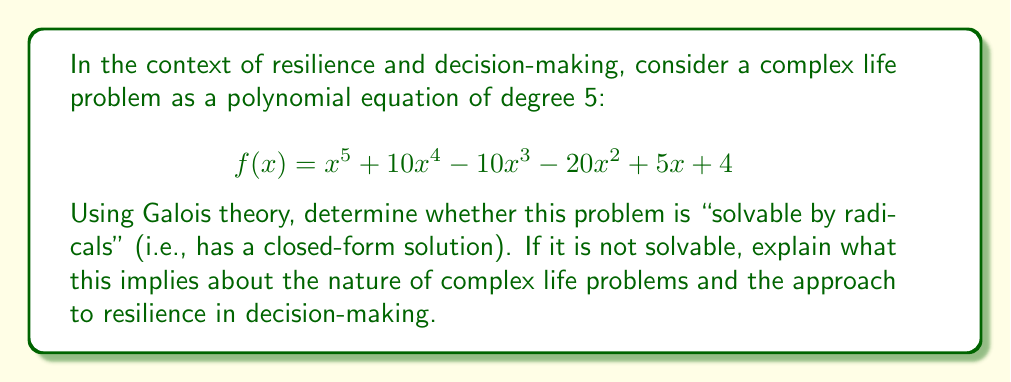What is the answer to this math problem? To determine if the polynomial is solvable by radicals, we'll use Galois theory:

1) First, we need to determine if the polynomial is irreducible over $\mathbb{Q}$. We can use Eisenstein's criterion with the prime $p=2$:
   - The leading coefficient is not divisible by 2
   - All other coefficients are divisible by 2
   - The constant term (4) is not divisible by $2^2 = 4$
   Therefore, $f(x)$ is irreducible over $\mathbb{Q}$.

2) Now, we need to find the Galois group of $f(x)$. Since $f(x)$ is of degree 5, its Galois group is a subgroup of $S_5$ (the symmetric group on 5 elements).

3) To determine the exact Galois group, we can use the fact that $f(x)$ has exactly three real roots (which can be verified graphically or numerically). This means the Galois group must contain a transposition (corresponding to complex conjugation of the two complex roots).

4) The only subgroups of $S_5$ that contain a transposition are $S_5$ itself and $A_5$ (the alternating group on 5 elements).

5) Since $f(x)$ is irreducible and of odd degree, its Galois group must be contained in $A_5$. Therefore, the Galois group of $f(x)$ is $A_5$.

6) By the Galois correspondence theorem, $f(x)$ is solvable by radicals if and only if its Galois group is solvable.

7) $A_5$ is the smallest non-solvable group, so $f(x)$ is not solvable by radicals.

In the context of resilience and decision-making, this result implies:

a) Complex life problems often don't have simple, closed-form solutions.
b) The process of solving such problems may require iterative approaches rather than direct formulas.
c) Resilience in decision-making involves accepting that some problems may not have clear-cut solutions and adapting strategies accordingly.
d) Just as we can approximate roots of unsolvable polynomials numerically, we can approach complex life problems through successive approximations and adjustments.
Answer: The polynomial $f(x) = x^5 + 10x^4 - 10x^3 - 20x^2 + 5x + 4$ is not solvable by radicals. This implies that complex life problems often lack simple, closed-form solutions, necessitating iterative and adaptive approaches in decision-making and resilience strategies. 